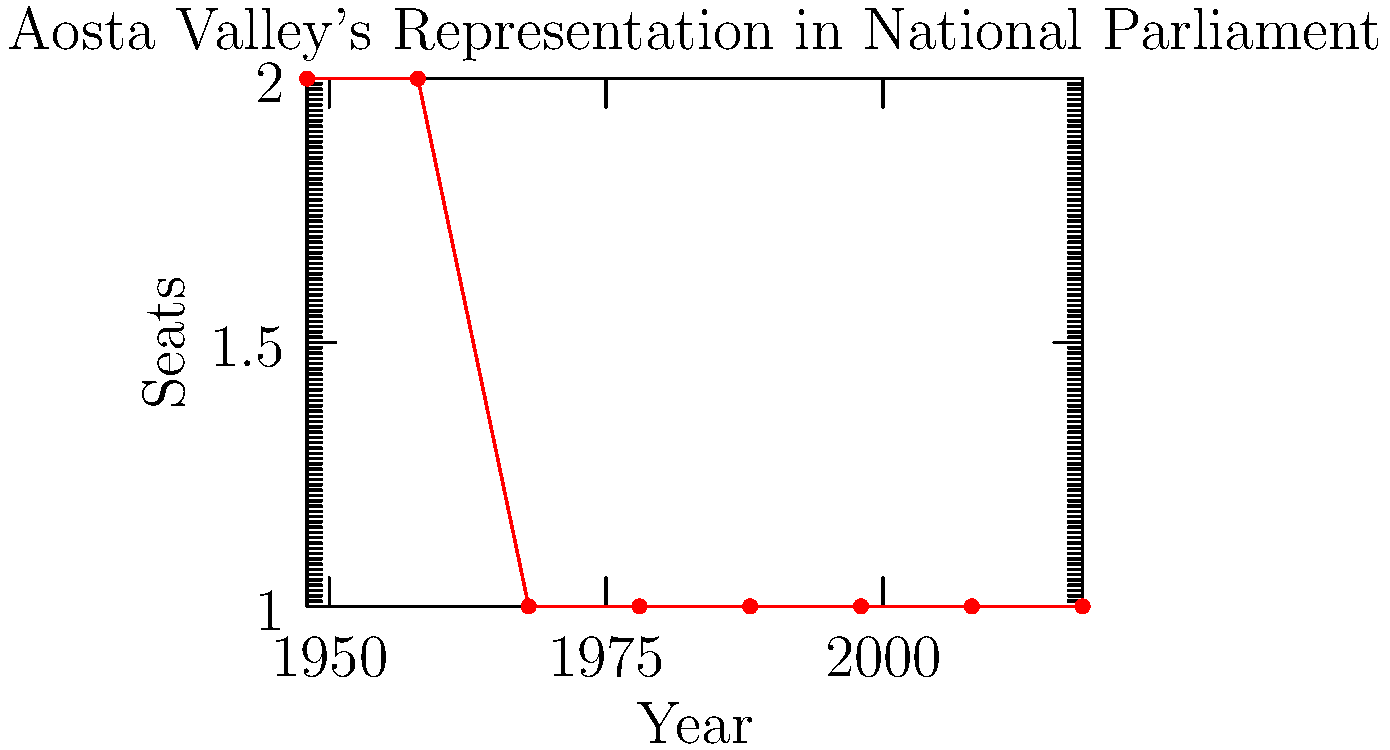Based on the line graph showing Aosta Valley's representation in the Italian national parliament over time, what significant change occurred between 1958 and 1968, and how might this have affected regional representation? To answer this question, let's analyze the graph step-by-step:

1. From 1948 to 1958, Aosta Valley had 2 seats in the national parliament.
2. Between 1958 and 1968, there's a decrease from 2 seats to 1 seat.
3. This reduction represents a 50% decrease in Aosta Valley's parliamentary representation.
4. From 1968 onwards, the representation remains constant at 1 seat.

The significant change between 1958 and 1968 was the loss of one seat, halving Aosta Valley's representation in the national parliament. This change likely affected regional representation in the following ways:

1. Reduced voice: With only one representative, Aosta Valley's ability to advocate for regional interests in the national parliament was diminished.
2. Increased pressure on the single representative: The remaining parliamentarian would have to work harder to represent all of Aosta Valley's diverse interests.
3. Potential for marginalization: With fewer representatives, Aosta Valley's issues might receive less attention in national debates.
4. Possible shift in political strategy: The region might have had to rely more on other forms of political engagement to compensate for reduced parliamentary representation.

This change highlights the challenges of maintaining adequate representation for small regions in a national political system.
Answer: Reduction from 2 to 1 seat, halving regional representation 